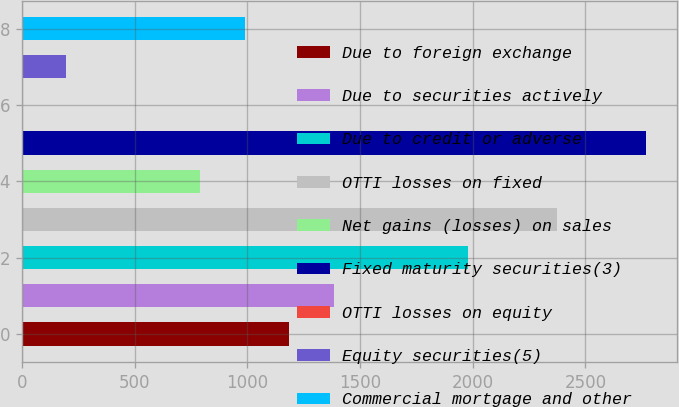Convert chart. <chart><loc_0><loc_0><loc_500><loc_500><bar_chart><fcel>Due to foreign exchange<fcel>Due to securities actively<fcel>Due to credit or adverse<fcel>OTTI losses on fixed<fcel>Net gains (losses) on sales<fcel>Fixed maturity securities(3)<fcel>OTTI losses on equity<fcel>Equity securities(5)<fcel>Commercial mortgage and other<nl><fcel>1186.28<fcel>1383.97<fcel>1977.04<fcel>2372.42<fcel>790.9<fcel>2767.8<fcel>0.14<fcel>197.83<fcel>988.59<nl></chart> 